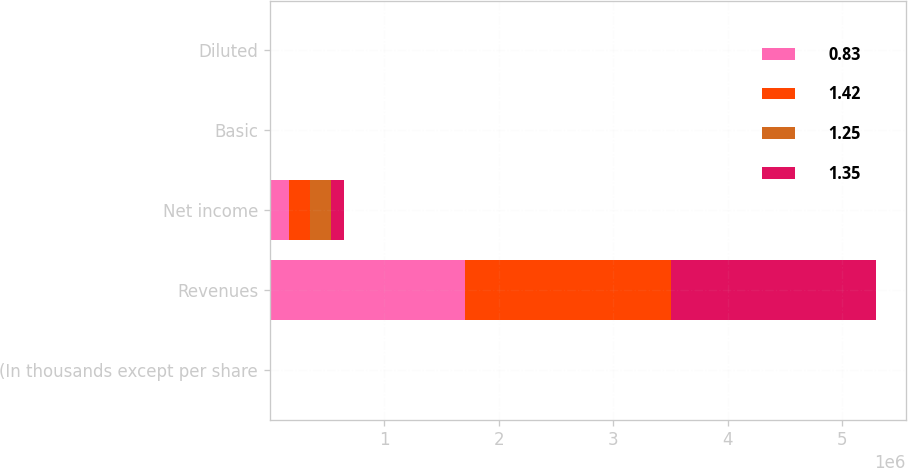<chart> <loc_0><loc_0><loc_500><loc_500><stacked_bar_chart><ecel><fcel>(In thousands except per share<fcel>Revenues<fcel>Net income<fcel>Basic<fcel>Diluted<nl><fcel>0.83<fcel>2014<fcel>1.70691e+06<fcel>169673<fcel>1.31<fcel>1.25<nl><fcel>1.42<fcel>2014<fcel>1.79699e+06<fcel>179961<fcel>1.41<fcel>1.35<nl><fcel>1.25<fcel>2014<fcel>2014<fcel>188539<fcel>1.48<fcel>1.42<nl><fcel>1.35<fcel>2014<fcel>1.78443e+06<fcel>110711<fcel>0.87<fcel>0.83<nl></chart> 